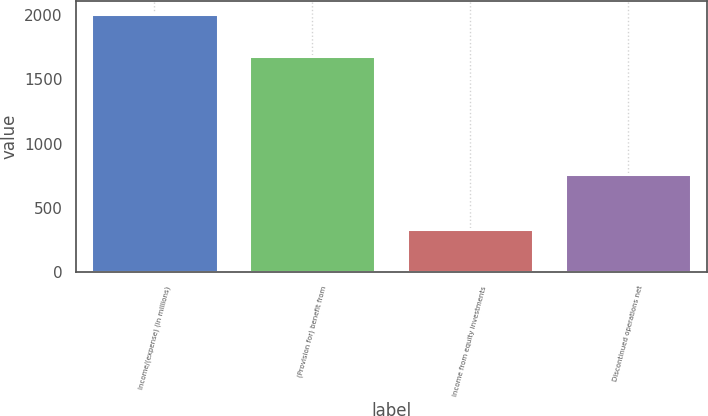<chart> <loc_0><loc_0><loc_500><loc_500><bar_chart><fcel>Income/(expense) (in millions)<fcel>(Provision for) benefit from<fcel>Income from equity investments<fcel>Discontinued operations net<nl><fcel>2014<fcel>1685<fcel>331<fcel>760<nl></chart> 